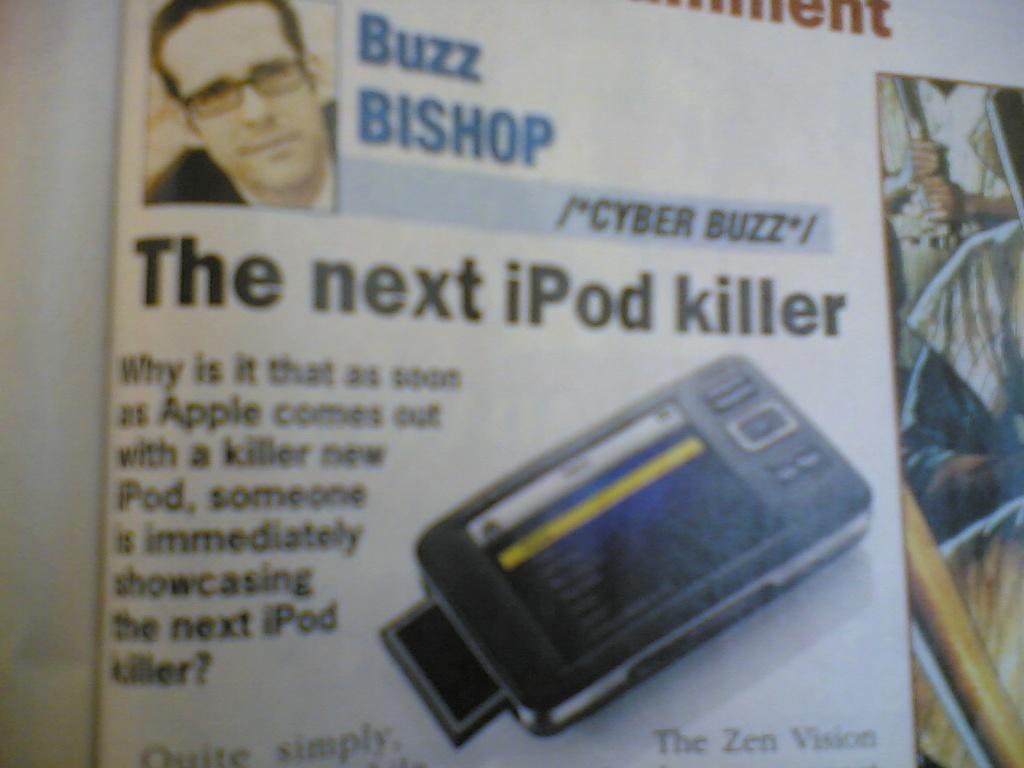Please provide a concise description of this image. In this image we can see an image of a paper. In the paper, we can see some text and images of persons and an electronic gadget. 